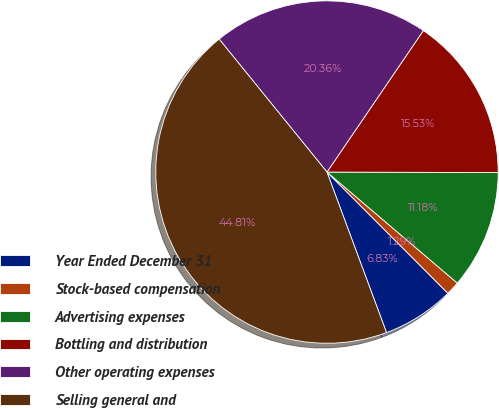Convert chart. <chart><loc_0><loc_0><loc_500><loc_500><pie_chart><fcel>Year Ended December 31<fcel>Stock-based compensation<fcel>Advertising expenses<fcel>Bottling and distribution<fcel>Other operating expenses<fcel>Selling general and<nl><fcel>6.83%<fcel>1.29%<fcel>11.18%<fcel>15.53%<fcel>20.36%<fcel>44.81%<nl></chart> 